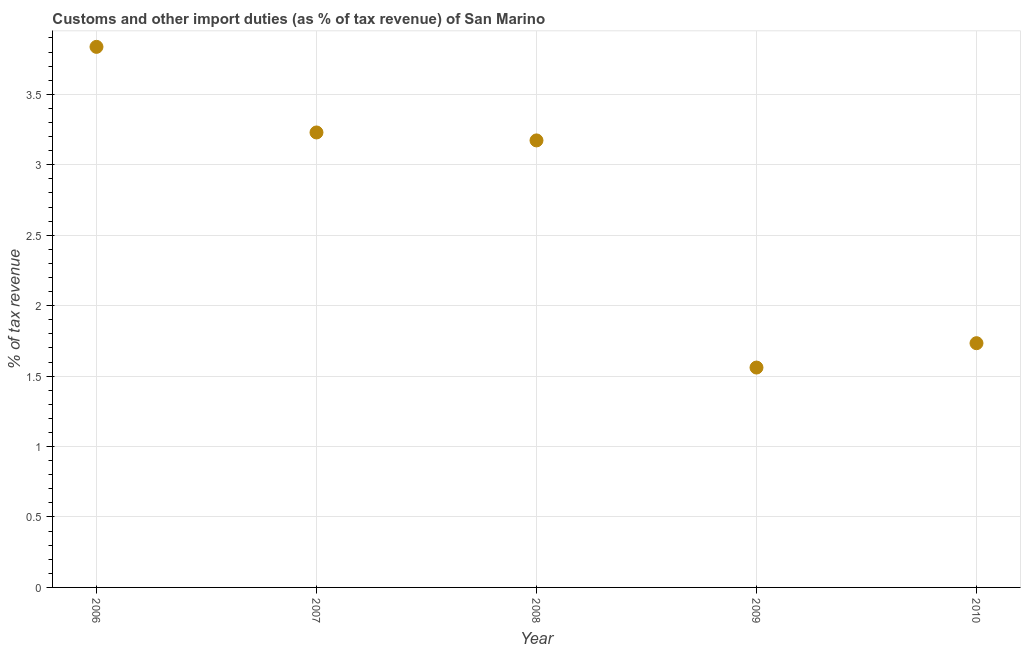What is the customs and other import duties in 2007?
Your answer should be very brief. 3.23. Across all years, what is the maximum customs and other import duties?
Offer a terse response. 3.84. Across all years, what is the minimum customs and other import duties?
Your response must be concise. 1.56. In which year was the customs and other import duties minimum?
Offer a terse response. 2009. What is the sum of the customs and other import duties?
Ensure brevity in your answer.  13.53. What is the difference between the customs and other import duties in 2006 and 2007?
Offer a very short reply. 0.61. What is the average customs and other import duties per year?
Your response must be concise. 2.71. What is the median customs and other import duties?
Offer a very short reply. 3.17. In how many years, is the customs and other import duties greater than 2 %?
Your answer should be very brief. 3. Do a majority of the years between 2010 and 2008 (inclusive) have customs and other import duties greater than 0.4 %?
Ensure brevity in your answer.  No. What is the ratio of the customs and other import duties in 2007 to that in 2010?
Your answer should be very brief. 1.86. Is the customs and other import duties in 2006 less than that in 2010?
Keep it short and to the point. No. What is the difference between the highest and the second highest customs and other import duties?
Keep it short and to the point. 0.61. Is the sum of the customs and other import duties in 2008 and 2010 greater than the maximum customs and other import duties across all years?
Your answer should be compact. Yes. What is the difference between the highest and the lowest customs and other import duties?
Give a very brief answer. 2.28. How many dotlines are there?
Your answer should be very brief. 1. Does the graph contain any zero values?
Your answer should be very brief. No. What is the title of the graph?
Provide a succinct answer. Customs and other import duties (as % of tax revenue) of San Marino. What is the label or title of the Y-axis?
Your answer should be very brief. % of tax revenue. What is the % of tax revenue in 2006?
Your response must be concise. 3.84. What is the % of tax revenue in 2007?
Provide a succinct answer. 3.23. What is the % of tax revenue in 2008?
Give a very brief answer. 3.17. What is the % of tax revenue in 2009?
Your answer should be compact. 1.56. What is the % of tax revenue in 2010?
Ensure brevity in your answer.  1.73. What is the difference between the % of tax revenue in 2006 and 2007?
Offer a terse response. 0.61. What is the difference between the % of tax revenue in 2006 and 2008?
Provide a short and direct response. 0.66. What is the difference between the % of tax revenue in 2006 and 2009?
Provide a succinct answer. 2.28. What is the difference between the % of tax revenue in 2006 and 2010?
Provide a short and direct response. 2.1. What is the difference between the % of tax revenue in 2007 and 2008?
Give a very brief answer. 0.06. What is the difference between the % of tax revenue in 2007 and 2009?
Ensure brevity in your answer.  1.67. What is the difference between the % of tax revenue in 2007 and 2010?
Keep it short and to the point. 1.5. What is the difference between the % of tax revenue in 2008 and 2009?
Your answer should be very brief. 1.61. What is the difference between the % of tax revenue in 2008 and 2010?
Offer a very short reply. 1.44. What is the difference between the % of tax revenue in 2009 and 2010?
Ensure brevity in your answer.  -0.17. What is the ratio of the % of tax revenue in 2006 to that in 2007?
Provide a short and direct response. 1.19. What is the ratio of the % of tax revenue in 2006 to that in 2008?
Offer a terse response. 1.21. What is the ratio of the % of tax revenue in 2006 to that in 2009?
Provide a short and direct response. 2.46. What is the ratio of the % of tax revenue in 2006 to that in 2010?
Your answer should be compact. 2.21. What is the ratio of the % of tax revenue in 2007 to that in 2008?
Your response must be concise. 1.02. What is the ratio of the % of tax revenue in 2007 to that in 2009?
Ensure brevity in your answer.  2.07. What is the ratio of the % of tax revenue in 2007 to that in 2010?
Offer a very short reply. 1.86. What is the ratio of the % of tax revenue in 2008 to that in 2009?
Keep it short and to the point. 2.03. What is the ratio of the % of tax revenue in 2008 to that in 2010?
Make the answer very short. 1.83. What is the ratio of the % of tax revenue in 2009 to that in 2010?
Your answer should be compact. 0.9. 